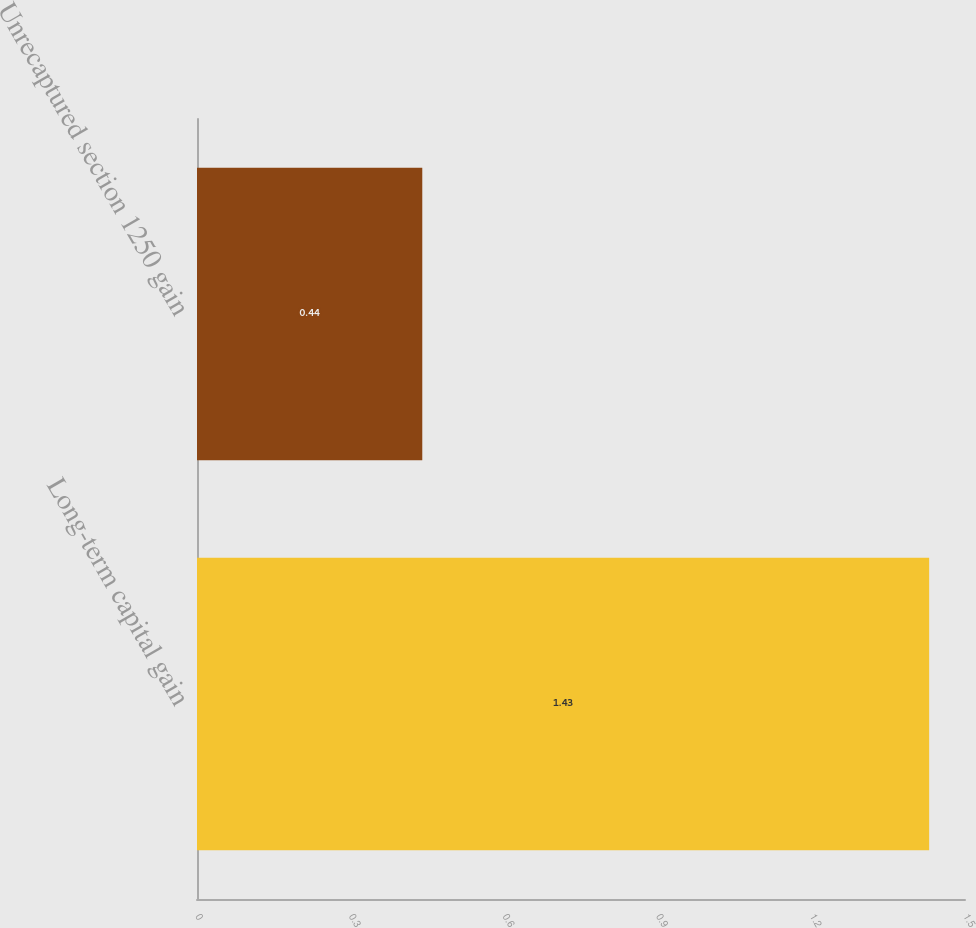Convert chart. <chart><loc_0><loc_0><loc_500><loc_500><bar_chart><fcel>Long-term capital gain<fcel>Unrecaptured section 1250 gain<nl><fcel>1.43<fcel>0.44<nl></chart> 